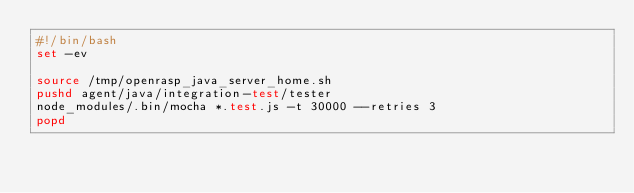Convert code to text. <code><loc_0><loc_0><loc_500><loc_500><_Bash_>#!/bin/bash
set -ev

source /tmp/openrasp_java_server_home.sh
pushd agent/java/integration-test/tester
node_modules/.bin/mocha *.test.js -t 30000 --retries 3
popd</code> 